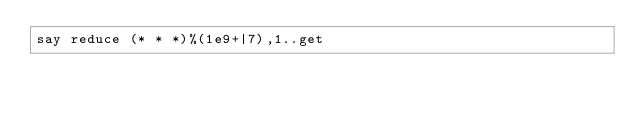Convert code to text. <code><loc_0><loc_0><loc_500><loc_500><_Perl_>say reduce (* * *)%(1e9+|7),1..get</code> 